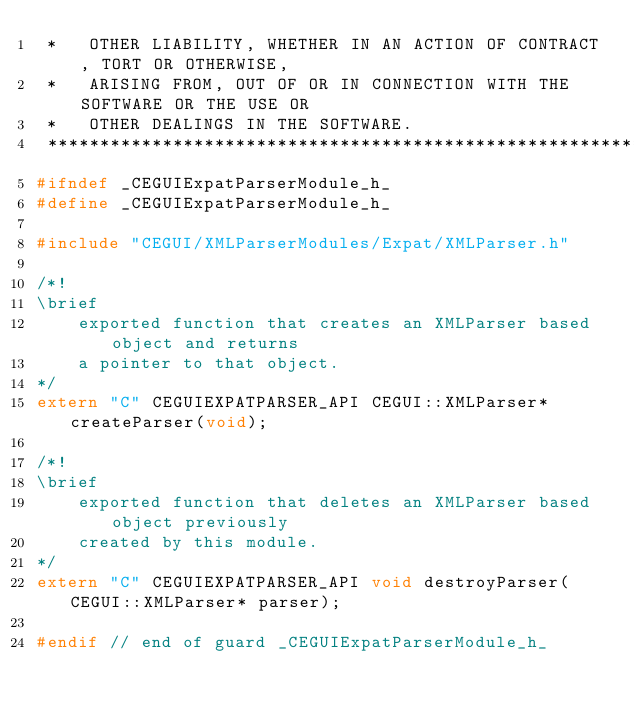<code> <loc_0><loc_0><loc_500><loc_500><_C_> *   OTHER LIABILITY, WHETHER IN AN ACTION OF CONTRACT, TORT OR OTHERWISE,
 *   ARISING FROM, OUT OF OR IN CONNECTION WITH THE SOFTWARE OR THE USE OR
 *   OTHER DEALINGS IN THE SOFTWARE.
 ***************************************************************************/
#ifndef _CEGUIExpatParserModule_h_
#define _CEGUIExpatParserModule_h_

#include "CEGUI/XMLParserModules/Expat/XMLParser.h"

/*!
\brief
    exported function that creates an XMLParser based object and returns
    a pointer to that object.
*/
extern "C" CEGUIEXPATPARSER_API CEGUI::XMLParser* createParser(void);

/*!
\brief
    exported function that deletes an XMLParser based object previously
    created by this module.
*/
extern "C" CEGUIEXPATPARSER_API void destroyParser(CEGUI::XMLParser* parser);

#endif // end of guard _CEGUIExpatParserModule_h_
</code> 